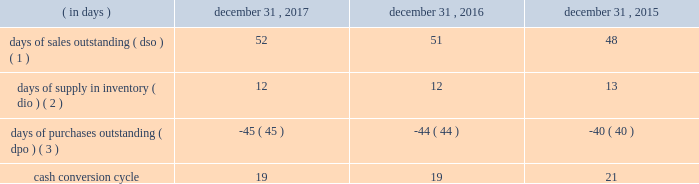Table of contents ( 4 ) the increase in cash flows was primarily due to the timing of inventory purchases and longer payment terms with certain vendors .
In order to manage our working capital and operating cash needs , we monitor our cash conversion cycle , defined as days of sales outstanding in accounts receivable plus days of supply in inventory minus days of purchases outstanding in accounts payable , based on a rolling three-month average .
Components of our cash conversion cycle are as follows: .
( 1 ) represents the rolling three-month average of the balance of accounts receivable , net at the end of the period , divided by average daily net sales for the same three-month period .
Also incorporates components of other miscellaneous receivables .
( 2 ) represents the rolling three-month average of the balance of merchandise inventory at the end of the period divided by average daily cost of sales for the same three-month period .
( 3 ) represents the rolling three-month average of the combined balance of accounts payable-trade , excluding cash overdrafts , and accounts payable-inventory financing at the end of the period divided by average daily cost of sales for the same three-month period .
The cash conversion cycle was 19 days at december 31 , 2017 and 2016 .
The increase in dso was primarily driven by higher net sales and related accounts receivable for third-party services such as saas , software assurance and warranties .
These services have an unfavorable impact on dso as the receivable is recognized on the consolidated balance sheet on a gross basis while the corresponding sales amount in the consolidated statement of operations is recorded on a net basis .
This also results in a favorable impact on dpo as the payable is recognized on the consolidated balance sheet without a corresponding cost of sales in the statement of operations because the cost paid to the vendor or third-party service provider is recorded as a reduction to net sales .
In addition , dpo also increased due to the mix of payables with certain vendors that have longer payment terms .
The cash conversion cycle was 19 and 21 days at december 31 , 2016 and 2015 , respectively .
The increase in dso was primarily driven by higher net sales and related accounts receivable for third-party services such as saas , software assurance and warranties .
These services have an unfavorable impact on dso as the receivable is recognized on the balance sheet on a gross basis while the corresponding sales amount in the statement of operations is recorded on a net basis .
These services have a favorable impact on dpo as the payable is recognized on the balance sheet without a corresponding cost of sale in the statement of operations because the cost paid to the vendor or third-party service provider is recorded as a reduction to net sales .
In addition to the impact of these services on dpo , dpo also increased due to the mix of payables with certain vendors that have longer payment terms .
Investing activities net cash used in investing activities increased $ 15 million in 2017 compared to 2016 .
Capital expenditures increased $ 17 million to $ 81 million from $ 64 million for 2017 and 2016 , respectively , primarily related to improvements to our information technology systems .
Net cash used in investing activities decreased $ 289 million in 2016 compared to 2015 .
The decrease in cash used was primarily due to the completion of the acquisition of cdw uk in 2015 .
Additionally , capital expenditures decreased $ 26 million to $ 64 million from $ 90 million for 2016 and 2015 , respectively , primarily due to spending for our new office location in 2015 .
Financing activities net cash used in financing activities increased $ 514 million in 2017 compared to 2016 .
The increase was primarily driven by changes in accounts payable-inventory financing , which resulted in an increase in cash used for financing activities of $ 228 million and by share repurchases during 2017 , which resulted in an increase in cash used for financing activities of $ 167 million .
For more information on our share repurchase program , see part ii , item 5 , 201cmarket for registrant 2019s common equity , related stockholder matters and issuer purchases of equity securities . 201d the increase in cash used for accounts payable-inventory financing was primarily driven by the termination of one of our inventory financing agreements in the fourth quarter of 2016 , with amounts .
In data what was the average cash conversion cycle for the three year period? 
Computations: table_average(cash conversion cycle, none)
Answer: 19.66667. 